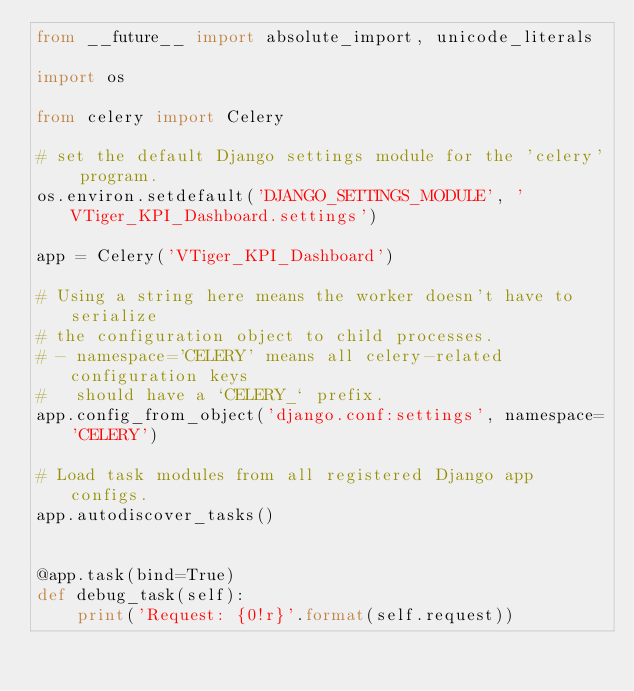Convert code to text. <code><loc_0><loc_0><loc_500><loc_500><_Python_>from __future__ import absolute_import, unicode_literals

import os

from celery import Celery

# set the default Django settings module for the 'celery' program.
os.environ.setdefault('DJANGO_SETTINGS_MODULE', 'VTiger_KPI_Dashboard.settings')

app = Celery('VTiger_KPI_Dashboard')

# Using a string here means the worker doesn't have to serialize
# the configuration object to child processes.
# - namespace='CELERY' means all celery-related configuration keys
#   should have a `CELERY_` prefix.
app.config_from_object('django.conf:settings', namespace='CELERY')

# Load task modules from all registered Django app configs.
app.autodiscover_tasks()


@app.task(bind=True)
def debug_task(self):
    print('Request: {0!r}'.format(self.request))</code> 